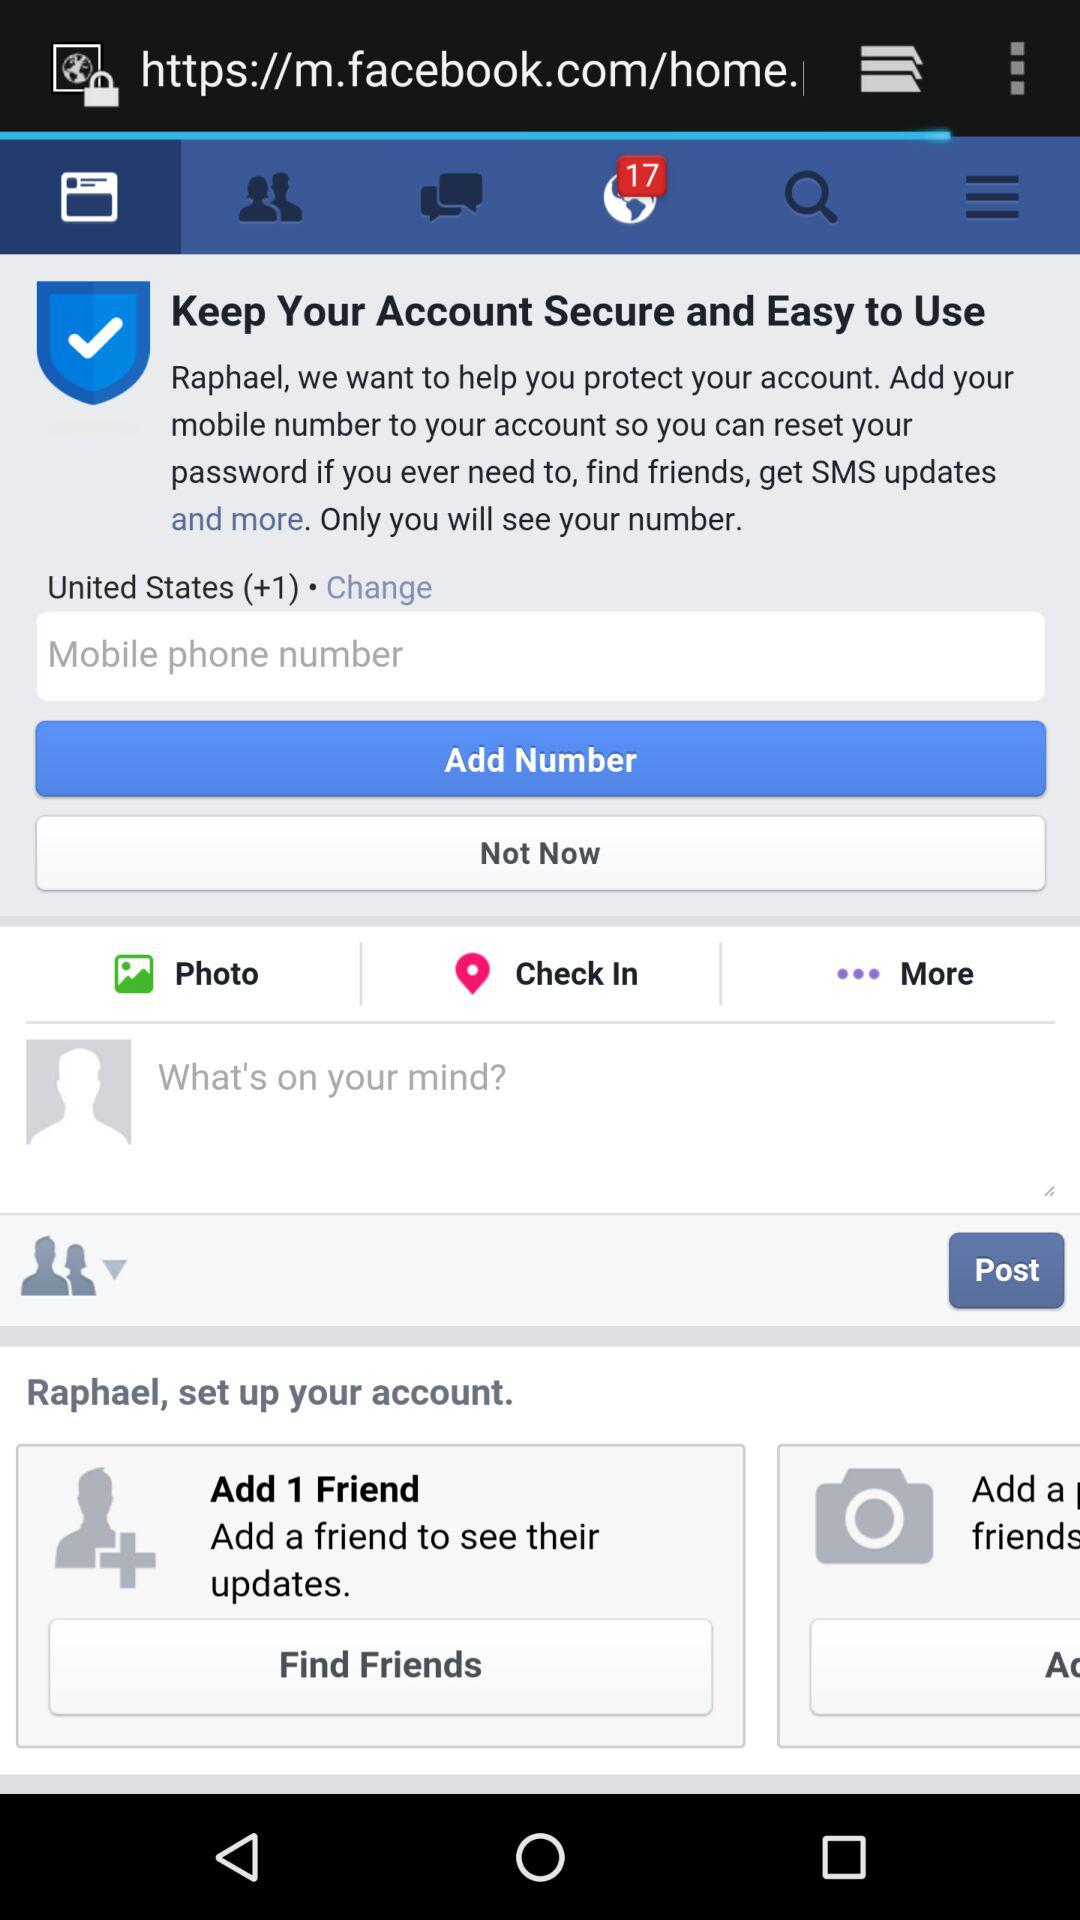How many unread notifications are there? There are 17 unread notifications. 